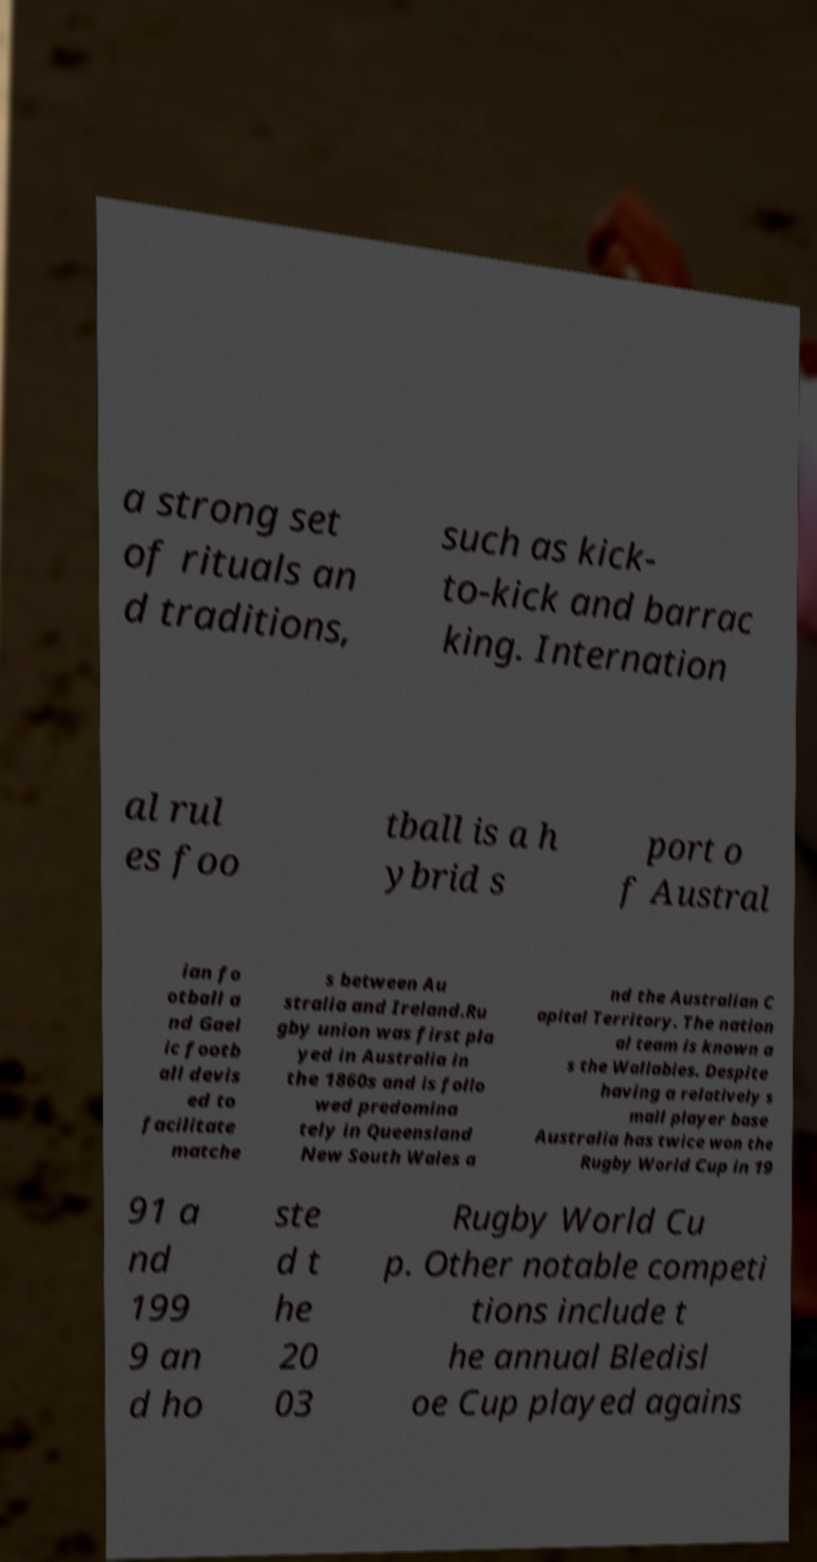Please identify and transcribe the text found in this image. a strong set of rituals an d traditions, such as kick- to-kick and barrac king. Internation al rul es foo tball is a h ybrid s port o f Austral ian fo otball a nd Gael ic footb all devis ed to facilitate matche s between Au stralia and Ireland.Ru gby union was first pla yed in Australia in the 1860s and is follo wed predomina tely in Queensland New South Wales a nd the Australian C apital Territory. The nation al team is known a s the Wallabies. Despite having a relatively s mall player base Australia has twice won the Rugby World Cup in 19 91 a nd 199 9 an d ho ste d t he 20 03 Rugby World Cu p. Other notable competi tions include t he annual Bledisl oe Cup played agains 